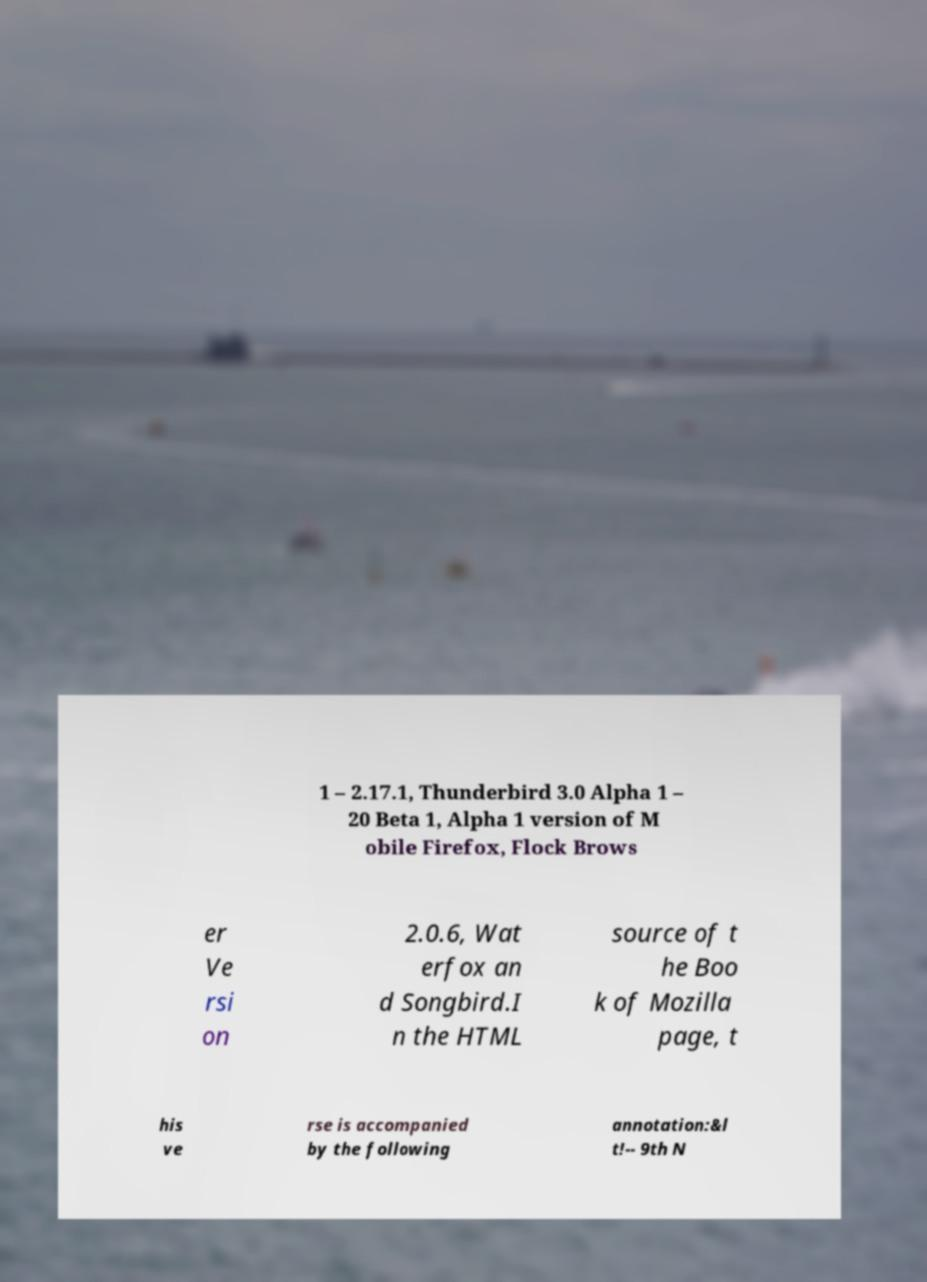Can you accurately transcribe the text from the provided image for me? 1 – 2.17.1, Thunderbird 3.0 Alpha 1 – 20 Beta 1, Alpha 1 version of M obile Firefox, Flock Brows er Ve rsi on 2.0.6, Wat erfox an d Songbird.I n the HTML source of t he Boo k of Mozilla page, t his ve rse is accompanied by the following annotation:&l t!-- 9th N 